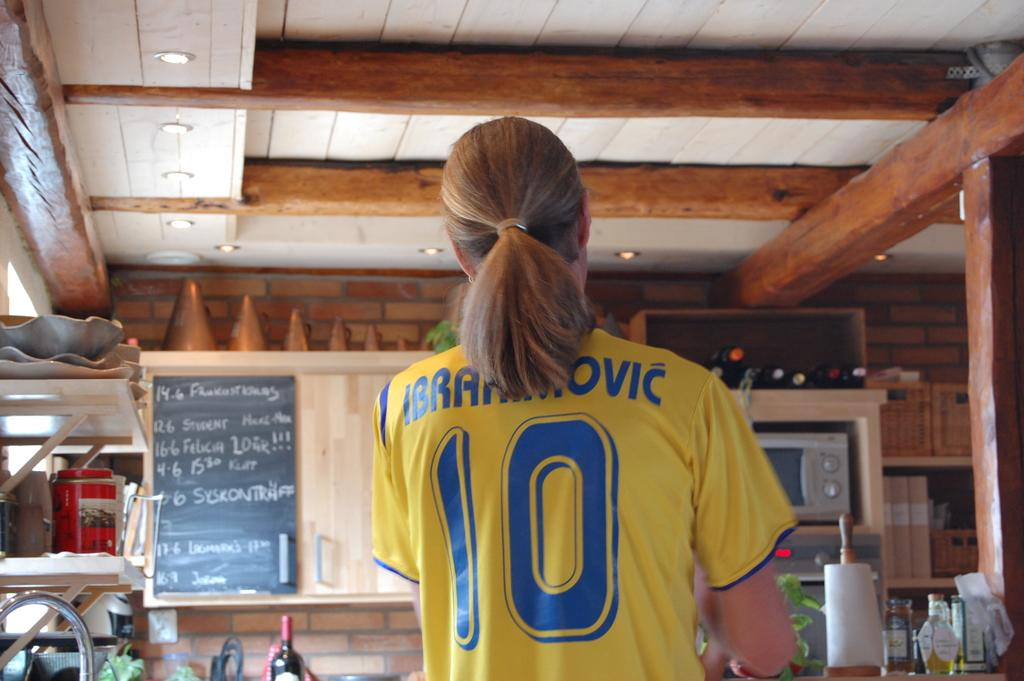<image>
Relay a brief, clear account of the picture shown. A woman in a yellow Ibrahimovic number 10 jersey 